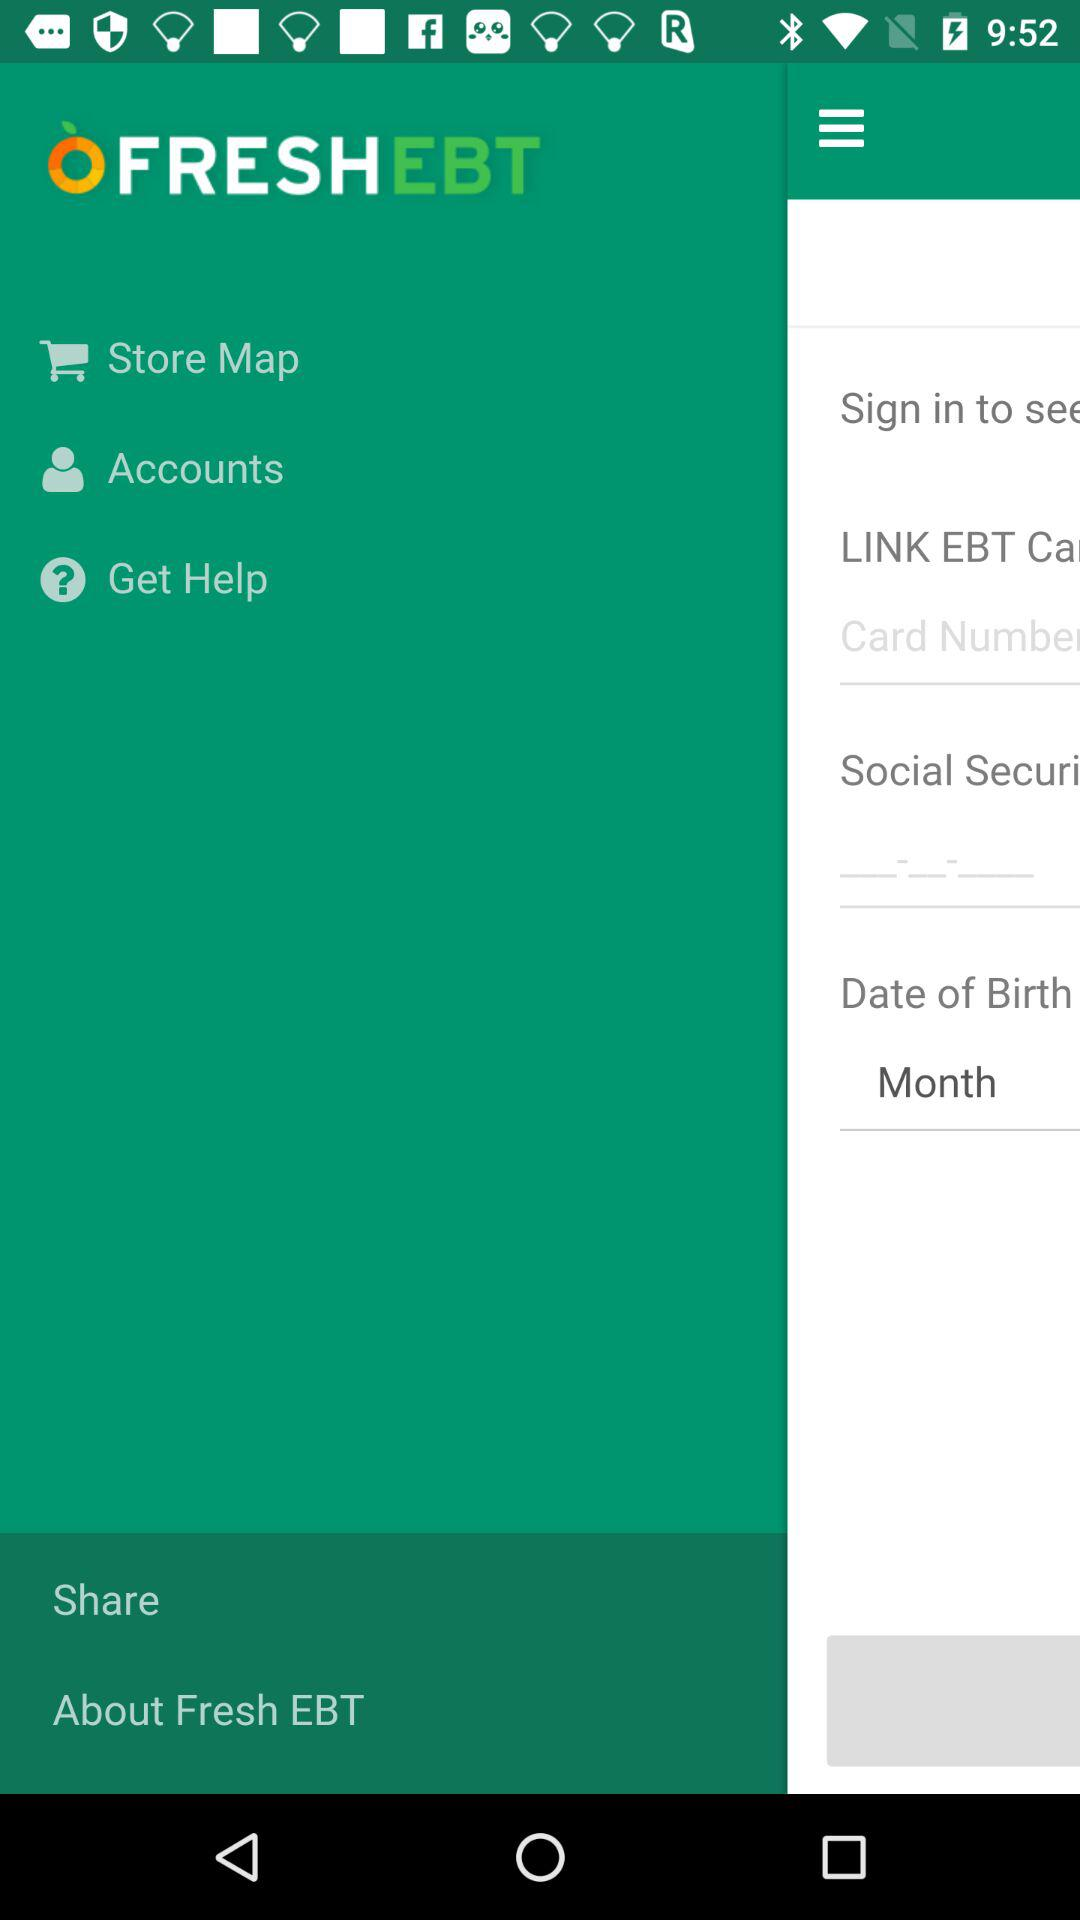What is the name of the application? The name of the application is "FRESHEBT". 